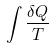<formula> <loc_0><loc_0><loc_500><loc_500>\int \frac { \delta Q } { T }</formula> 